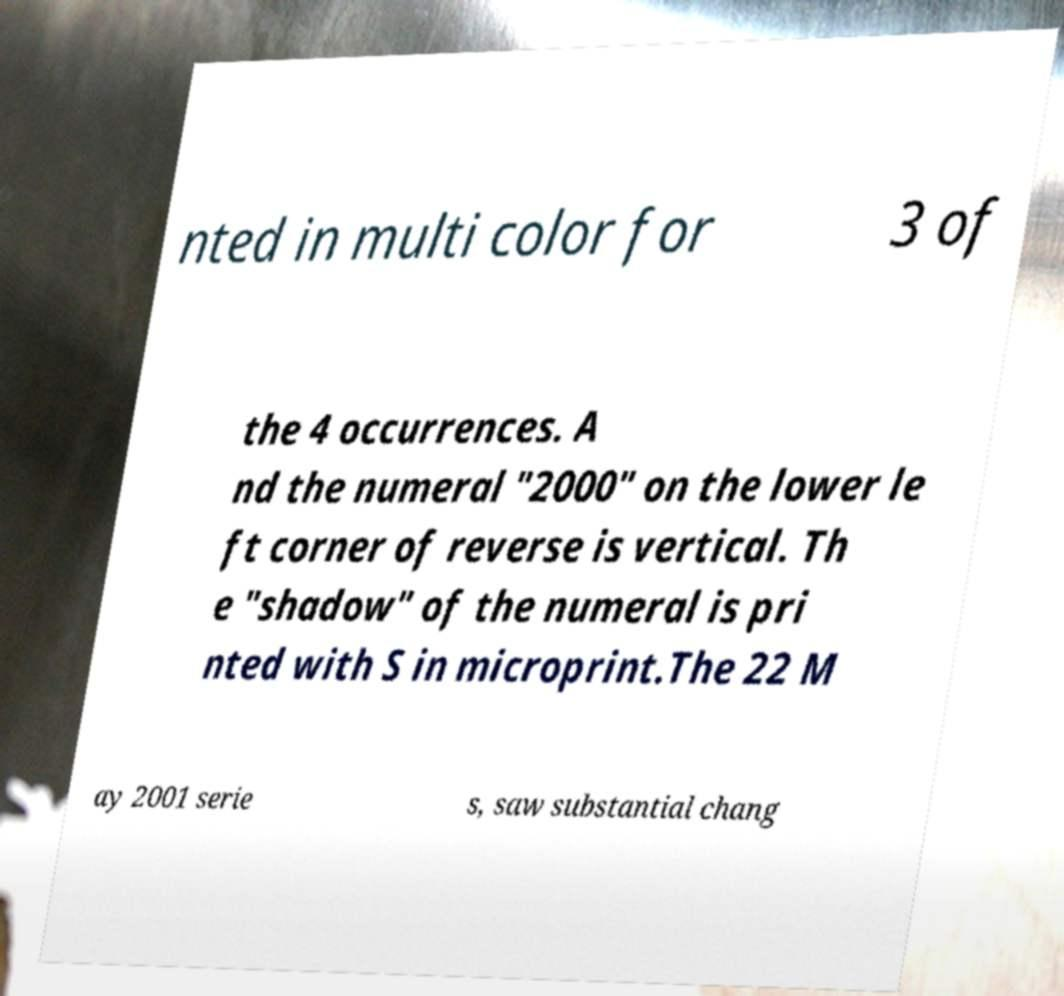What messages or text are displayed in this image? I need them in a readable, typed format. nted in multi color for 3 of the 4 occurrences. A nd the numeral "2000" on the lower le ft corner of reverse is vertical. Th e "shadow" of the numeral is pri nted with S in microprint.The 22 M ay 2001 serie s, saw substantial chang 